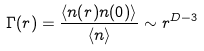Convert formula to latex. <formula><loc_0><loc_0><loc_500><loc_500>\Gamma ( r ) = \frac { \langle n ( r ) n ( 0 ) \rangle } { \langle n \rangle } \sim r ^ { D - 3 }</formula> 